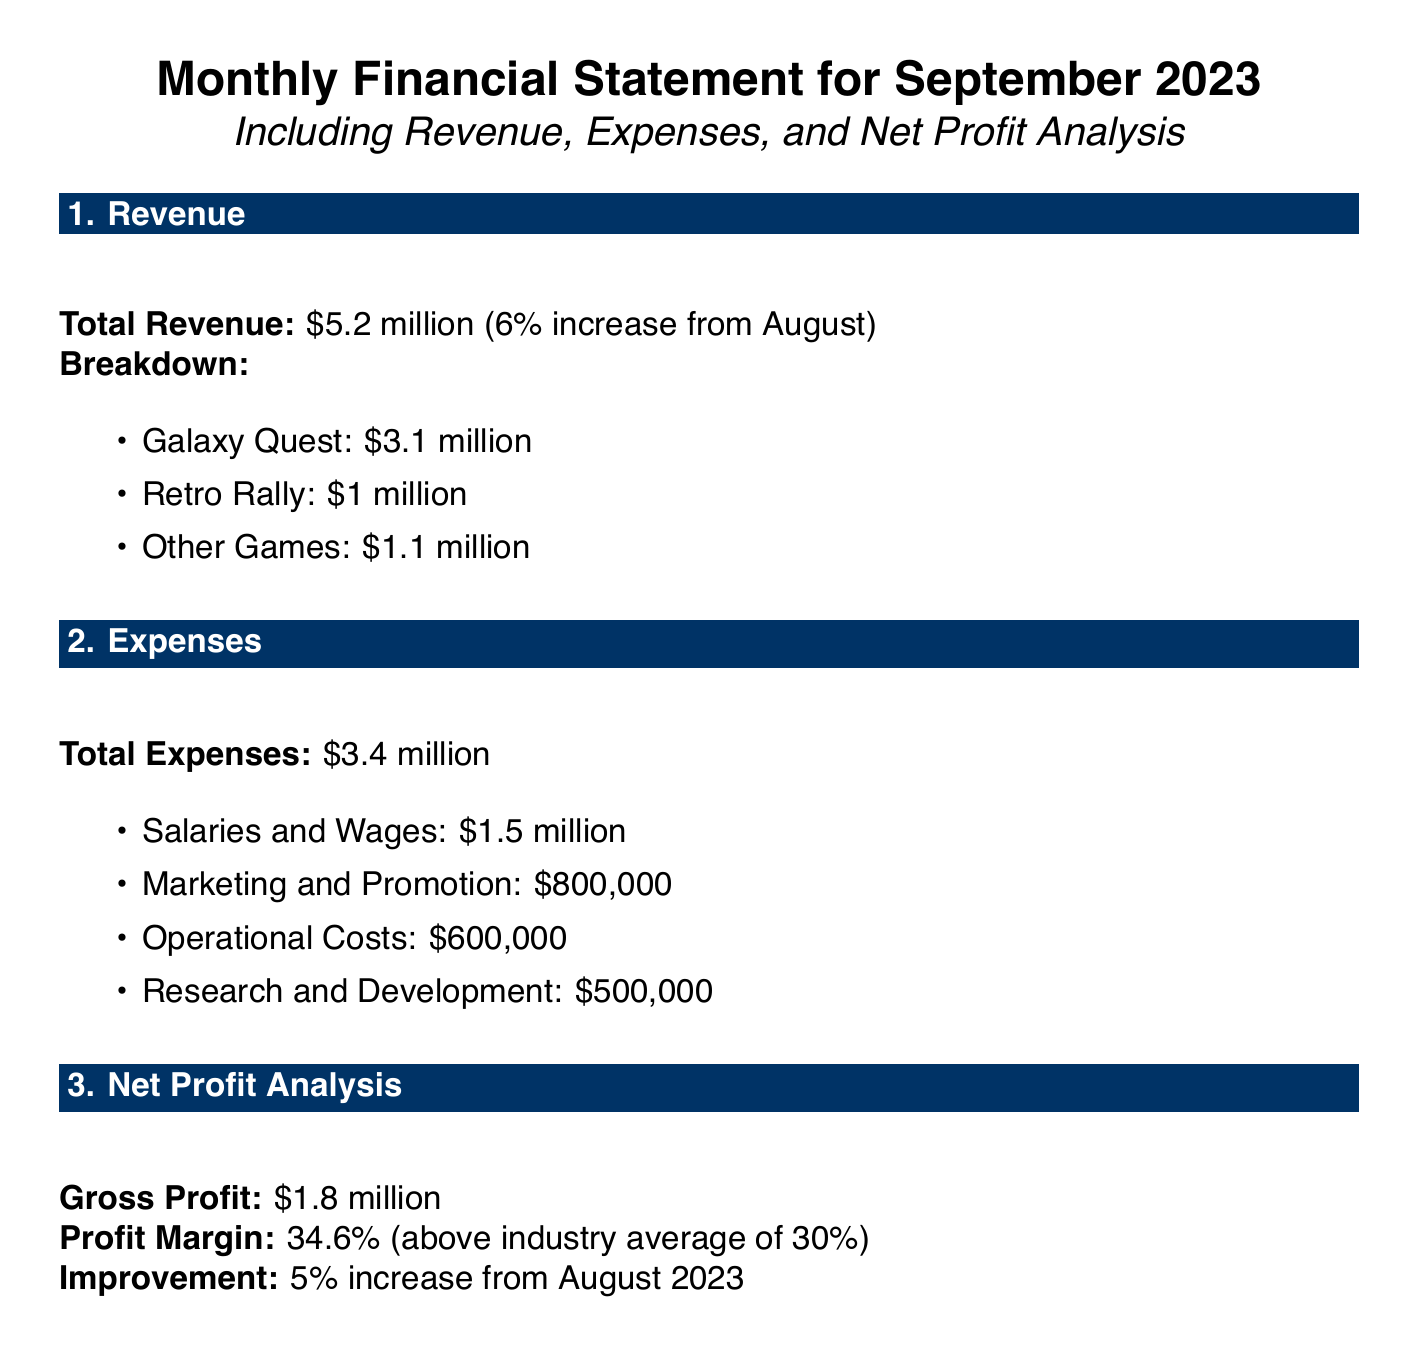What is the total revenue for September 2023? The total revenue is provided directly in the document, amounting to $5.2 million.
Answer: $5.2 million What was the revenue from Galaxy Quest? The document specifies that Galaxy Quest contributed $3.1 million to the total revenue.
Answer: $3.1 million What are the total expenses recorded for September 2023? The document indicates that total expenses amount to $3.4 million.
Answer: $3.4 million What is the gross profit reported in the document? The gross profit is stated in the document as $1.8 million.
Answer: $1.8 million What is the profit margin percentage for September 2023? The profit margin is calculated based on gross profit and total revenue, reported as 34.6%.
Answer: 34.6% How much did the salaries and wages account for in the expenses? The document outlines that salaries and wages expenses were $1.5 million.
Answer: $1.5 million What is the increase percentage in total revenue compared to August? The document notes that there is a 6% increase in total revenue compared to August.
Answer: 6% What is the amount spent on marketing and promotion? According to the document, the expenses for marketing and promotion were $800,000.
Answer: $800,000 How much revenue did 'Other Games' generate? The document specifies that 'Other Games' generated $1.1 million in revenue.
Answer: $1.1 million What is the improvement in net profit compared to the previous month? The document states there was a 5% increase in net profit compared to August 2023.
Answer: 5% 